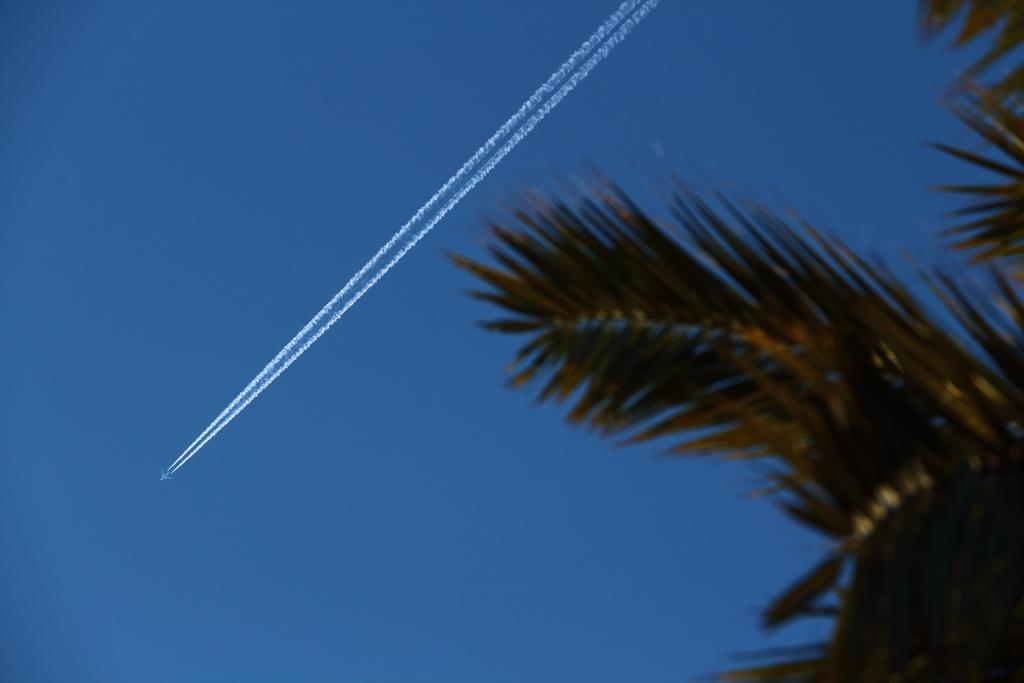What type of natural elements can be seen in the image? There are leaves in the image. What can be seen in the sky in the background of the image? There is a jet flying in the sky in the background of the image. What type of drum is the queen playing in the image? There is no drum or queen present in the image; it only features leaves and a jet flying in the sky. 